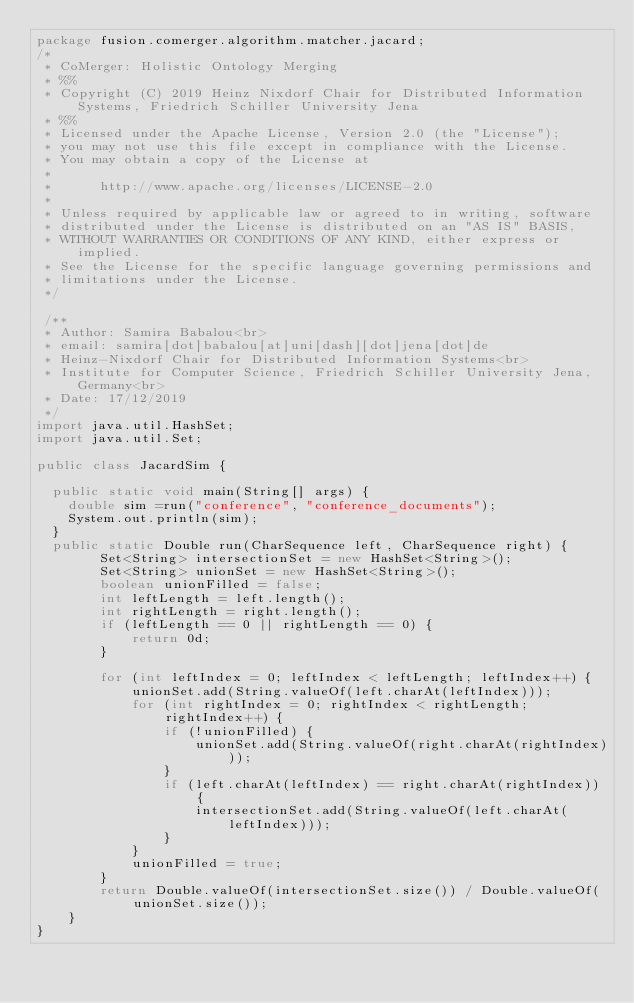Convert code to text. <code><loc_0><loc_0><loc_500><loc_500><_Java_>package fusion.comerger.algorithm.matcher.jacard;
/*
 * CoMerger: Holistic Ontology Merging
 * %%
 * Copyright (C) 2019 Heinz Nixdorf Chair for Distributed Information Systems, Friedrich Schiller University Jena
 * %%
 * Licensed under the Apache License, Version 2.0 (the "License");
 * you may not use this file except in compliance with the License.
 * You may obtain a copy of the License at
 * 
 *      http://www.apache.org/licenses/LICENSE-2.0
 * 
 * Unless required by applicable law or agreed to in writing, software
 * distributed under the License is distributed on an "AS IS" BASIS,
 * WITHOUT WARRANTIES OR CONDITIONS OF ANY KIND, either express or implied.
 * See the License for the specific language governing permissions and
 * limitations under the License.
 */
 
 /**
 * Author: Samira Babalou<br>
 * email: samira[dot]babalou[at]uni[dash][dot]jena[dot]de
 * Heinz-Nixdorf Chair for Distributed Information Systems<br>
 * Institute for Computer Science, Friedrich Schiller University Jena, Germany<br>
 * Date: 17/12/2019
 */
import java.util.HashSet;
import java.util.Set;

public class JacardSim {

	public static void main(String[] args) {
		double sim =run("conference", "conference_documents");
		System.out.println(sim);
	}
	public static Double run(CharSequence left, CharSequence right) {
        Set<String> intersectionSet = new HashSet<String>();
        Set<String> unionSet = new HashSet<String>();
        boolean unionFilled = false;
        int leftLength = left.length();
        int rightLength = right.length();
        if (leftLength == 0 || rightLength == 0) {
            return 0d;
        }

        for (int leftIndex = 0; leftIndex < leftLength; leftIndex++) {
            unionSet.add(String.valueOf(left.charAt(leftIndex)));
            for (int rightIndex = 0; rightIndex < rightLength; rightIndex++) {
                if (!unionFilled) {
                    unionSet.add(String.valueOf(right.charAt(rightIndex)));
                }
                if (left.charAt(leftIndex) == right.charAt(rightIndex)) {
                    intersectionSet.add(String.valueOf(left.charAt(leftIndex)));
                }
            }
            unionFilled = true;
        }
        return Double.valueOf(intersectionSet.size()) / Double.valueOf(unionSet.size());
    }
}
</code> 